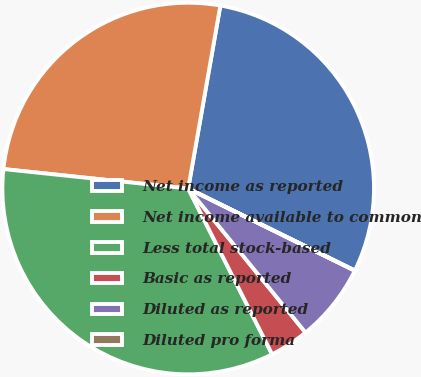Convert chart. <chart><loc_0><loc_0><loc_500><loc_500><pie_chart><fcel>Net income as reported<fcel>Net income available to common<fcel>Less total stock-based<fcel>Basic as reported<fcel>Diluted as reported<fcel>Diluted pro forma<nl><fcel>29.51%<fcel>26.1%<fcel>34.13%<fcel>3.42%<fcel>6.83%<fcel>0.01%<nl></chart> 